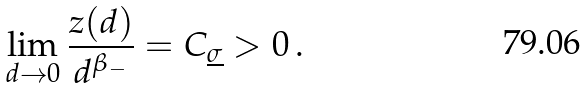<formula> <loc_0><loc_0><loc_500><loc_500>\lim _ { d \to 0 } \frac { z ( d ) } { d ^ { \beta _ { - } } } = C _ { \underline { \sigma } } > 0 \, .</formula> 